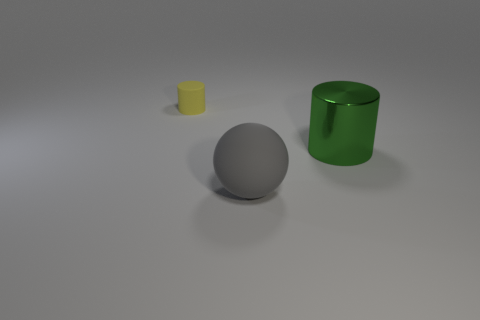What number of yellow things are either big cylinders or spheres?
Provide a succinct answer. 0. There is a matte thing that is on the right side of the tiny cylinder; what number of yellow things are to the right of it?
Make the answer very short. 0. Are there more green objects that are in front of the gray sphere than yellow matte things behind the yellow cylinder?
Ensure brevity in your answer.  No. What is the material of the small yellow object?
Your answer should be compact. Rubber. Are there any cylinders that have the same size as the sphere?
Ensure brevity in your answer.  Yes. There is a thing that is the same size as the green metallic cylinder; what material is it?
Your answer should be compact. Rubber. What number of big red rubber objects are there?
Provide a succinct answer. 0. There is a thing that is right of the gray rubber object; how big is it?
Offer a very short reply. Large. Are there the same number of cylinders to the right of the big gray rubber ball and small green cylinders?
Offer a very short reply. No. Are there any yellow matte objects of the same shape as the gray object?
Keep it short and to the point. No. 